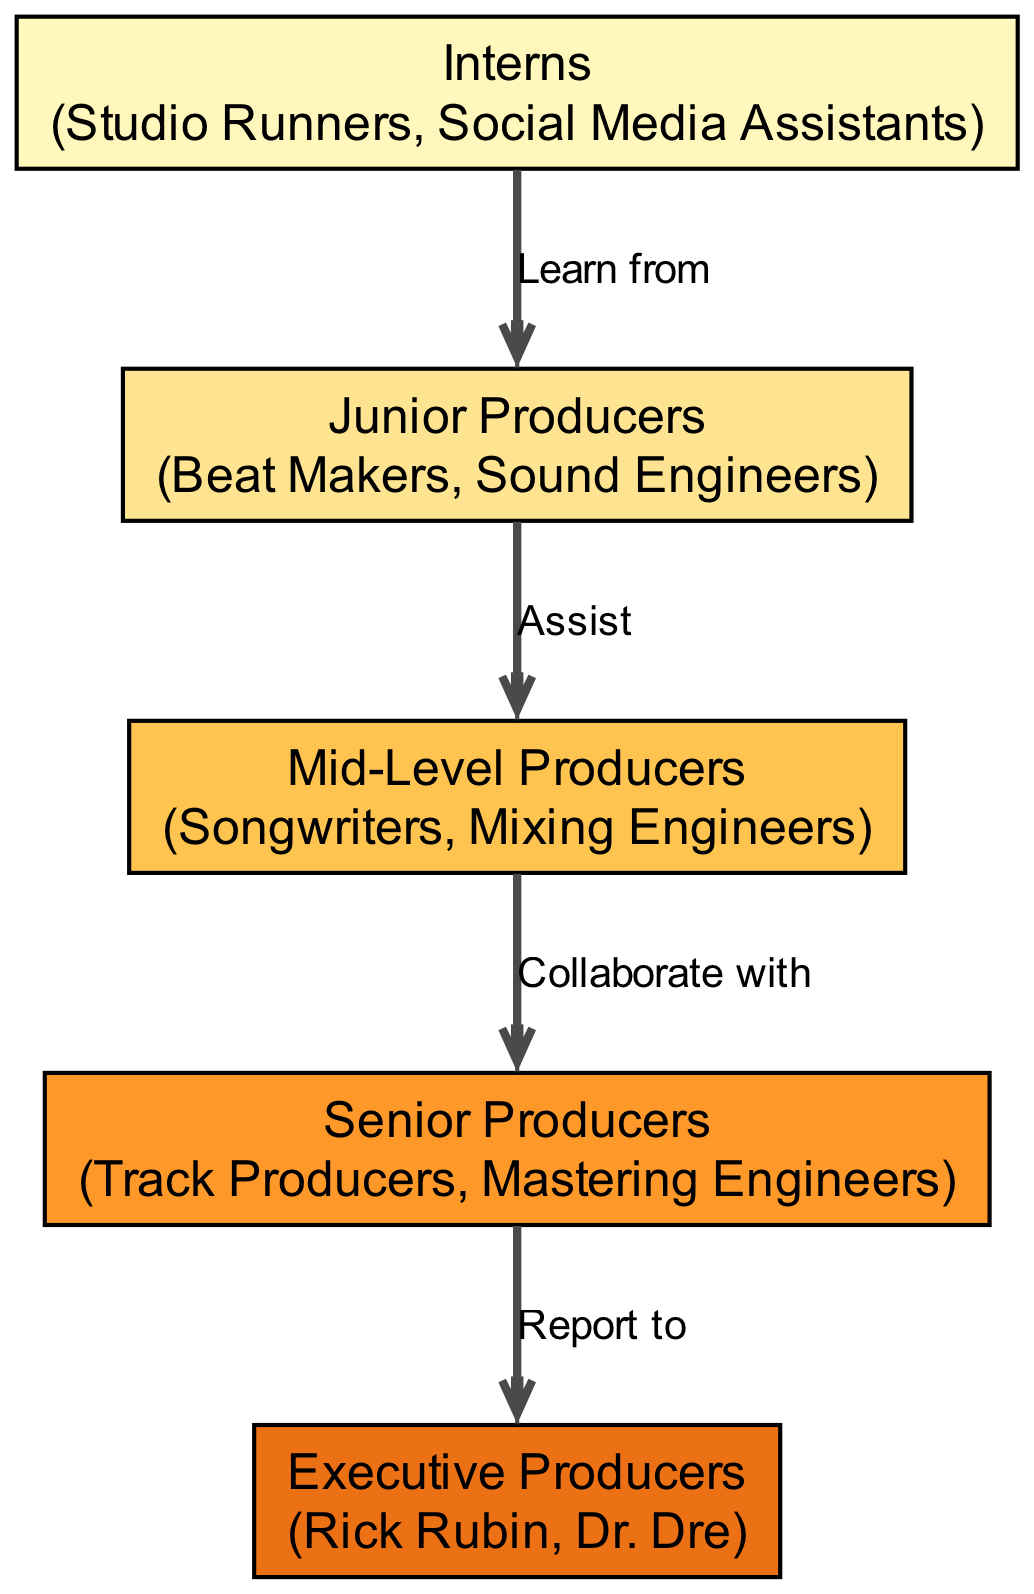What is the lowest trophic level in the diagram? The diagram presents five trophic levels, starting from "Interns," which is shown at the bottom of the hierarchy. Therefore, "Interns" represents the lowest trophic level.
Answer: Interns How many examples are listed for Senior Producers? By examining the node for "Senior Producers," we see that it includes two examples: "Track Producers" and "Mastering Engineers." Hence, the count of examples is two.
Answer: 2 Who do Mid-Level Producers collaborate with? Following the arrows from "Mid-Level Producers" in the diagram, we see that they are stated to "Collaborate with" "Senior Producers." This clearly indicates the direct relationship displayed.
Answer: Senior Producers Which level do Junior Producers assist? The relationship from "Junior Producers" in the diagram shows that they "Assist" "Mid-Level Producers." This connection illustrates the flow from one level of the hierarchy to the next.
Answer: Mid-Level Producers What is the total number of nodes in the diagram? The diagram includes five distinct nodes corresponding to the different trophic levels: Interns, Junior Producers, Mid-Level Producers, Senior Producers, and Executive Producers. Counting these nodes gives us a total of five.
Answer: 5 Who do Senior Producers report to? Referring to the arrow connecting "Senior Producers" to "Executive Producers," we find the indication that they "Report to" "Executive Producers." This relationship illustrates the tiered structure of the music industry hierarchy.
Answer: Executive Producers What color represents Junior Producers? In analyzing the color scheme of the diagram, we see that "Junior Producers" is associated with the light yellow color (#FEE391). This corresponds to the second trophic level as per the established color palette.
Answer: #FEE391 What type of professionals form the third trophic level? The third trophic level, labeled "Mid-Level Producers," consists of two types of professionals: "Songwriters" and "Mixing Engineers." This detail is specified in the node for that level.
Answer: Songwriters, Mixing Engineers 